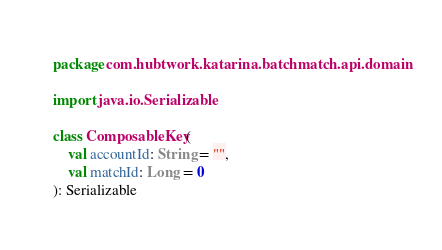Convert code to text. <code><loc_0><loc_0><loc_500><loc_500><_Kotlin_>package com.hubtwork.katarina.batchmatch.api.domain

import java.io.Serializable

class ComposableKey(
    val accountId: String = "",
    val matchId: Long = 0
): Serializable</code> 